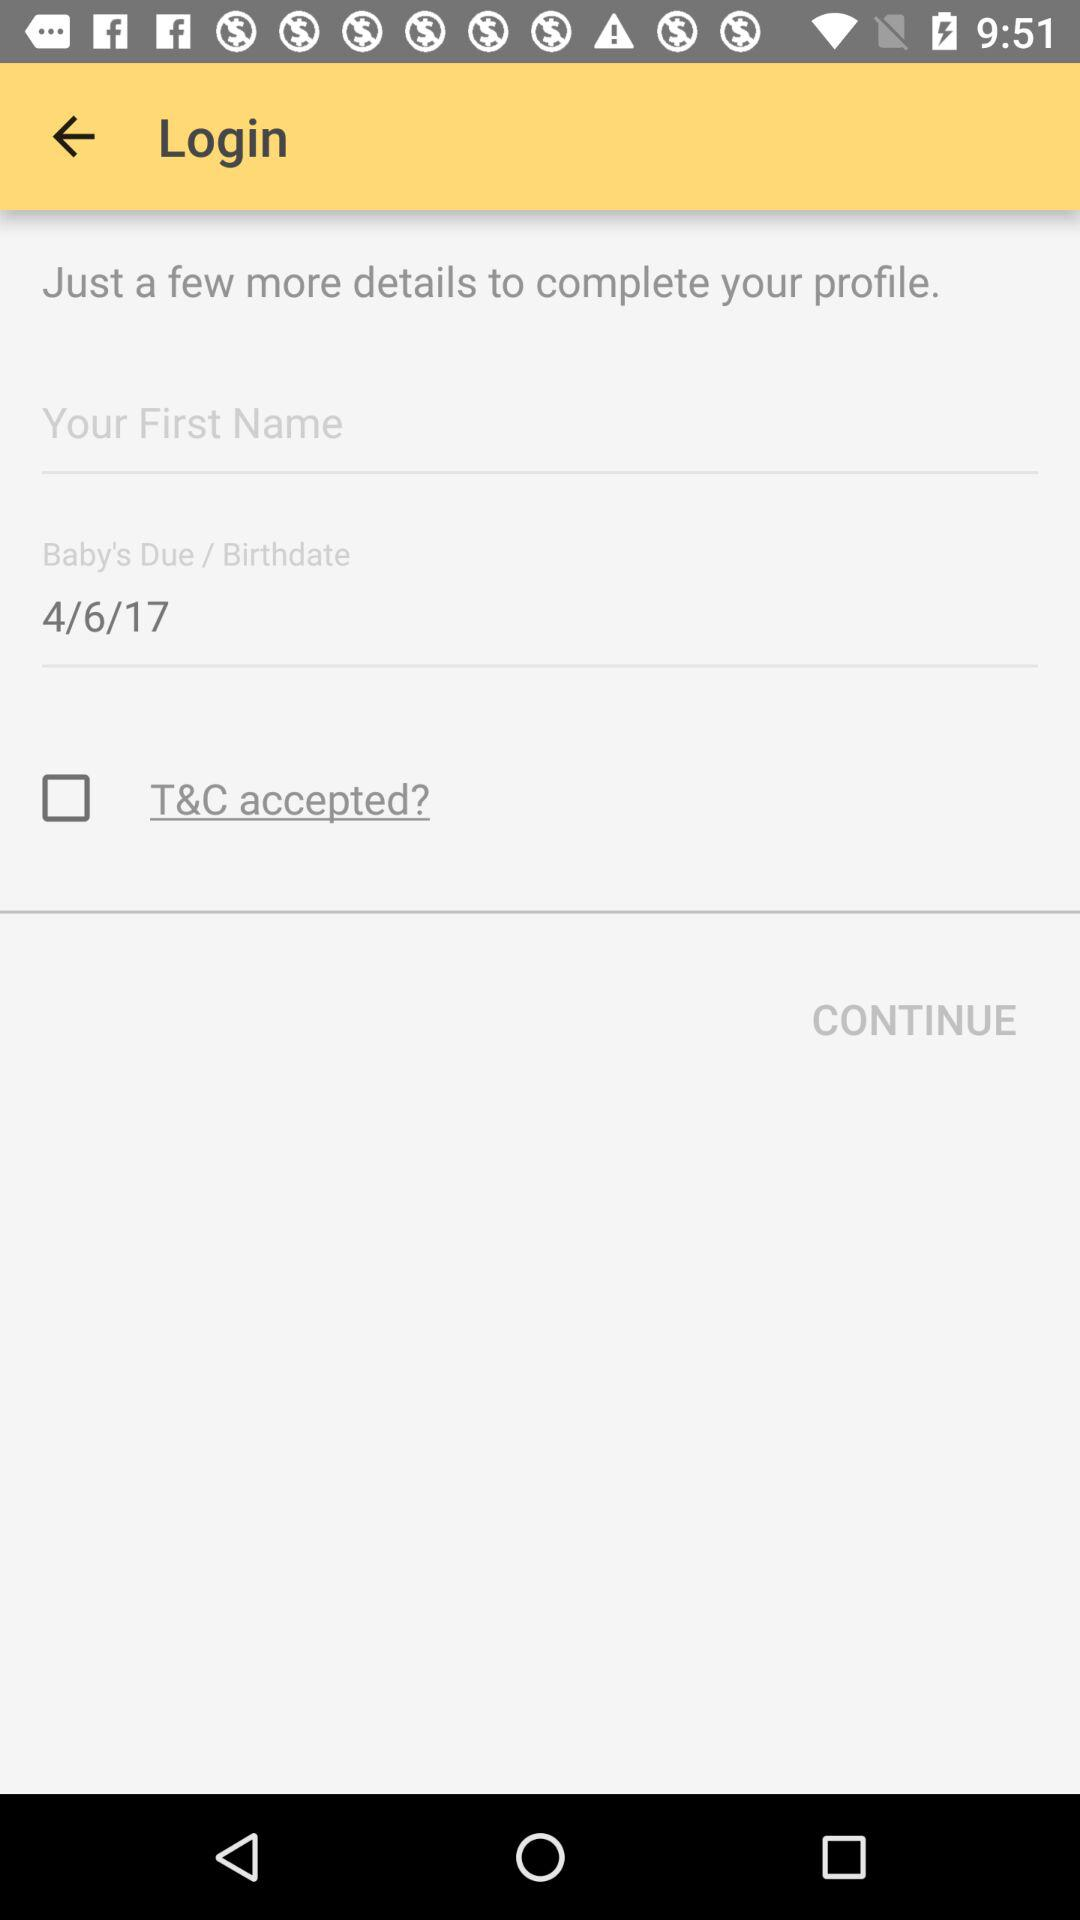What is the status of "T&C accepted?"? The status is "off". 